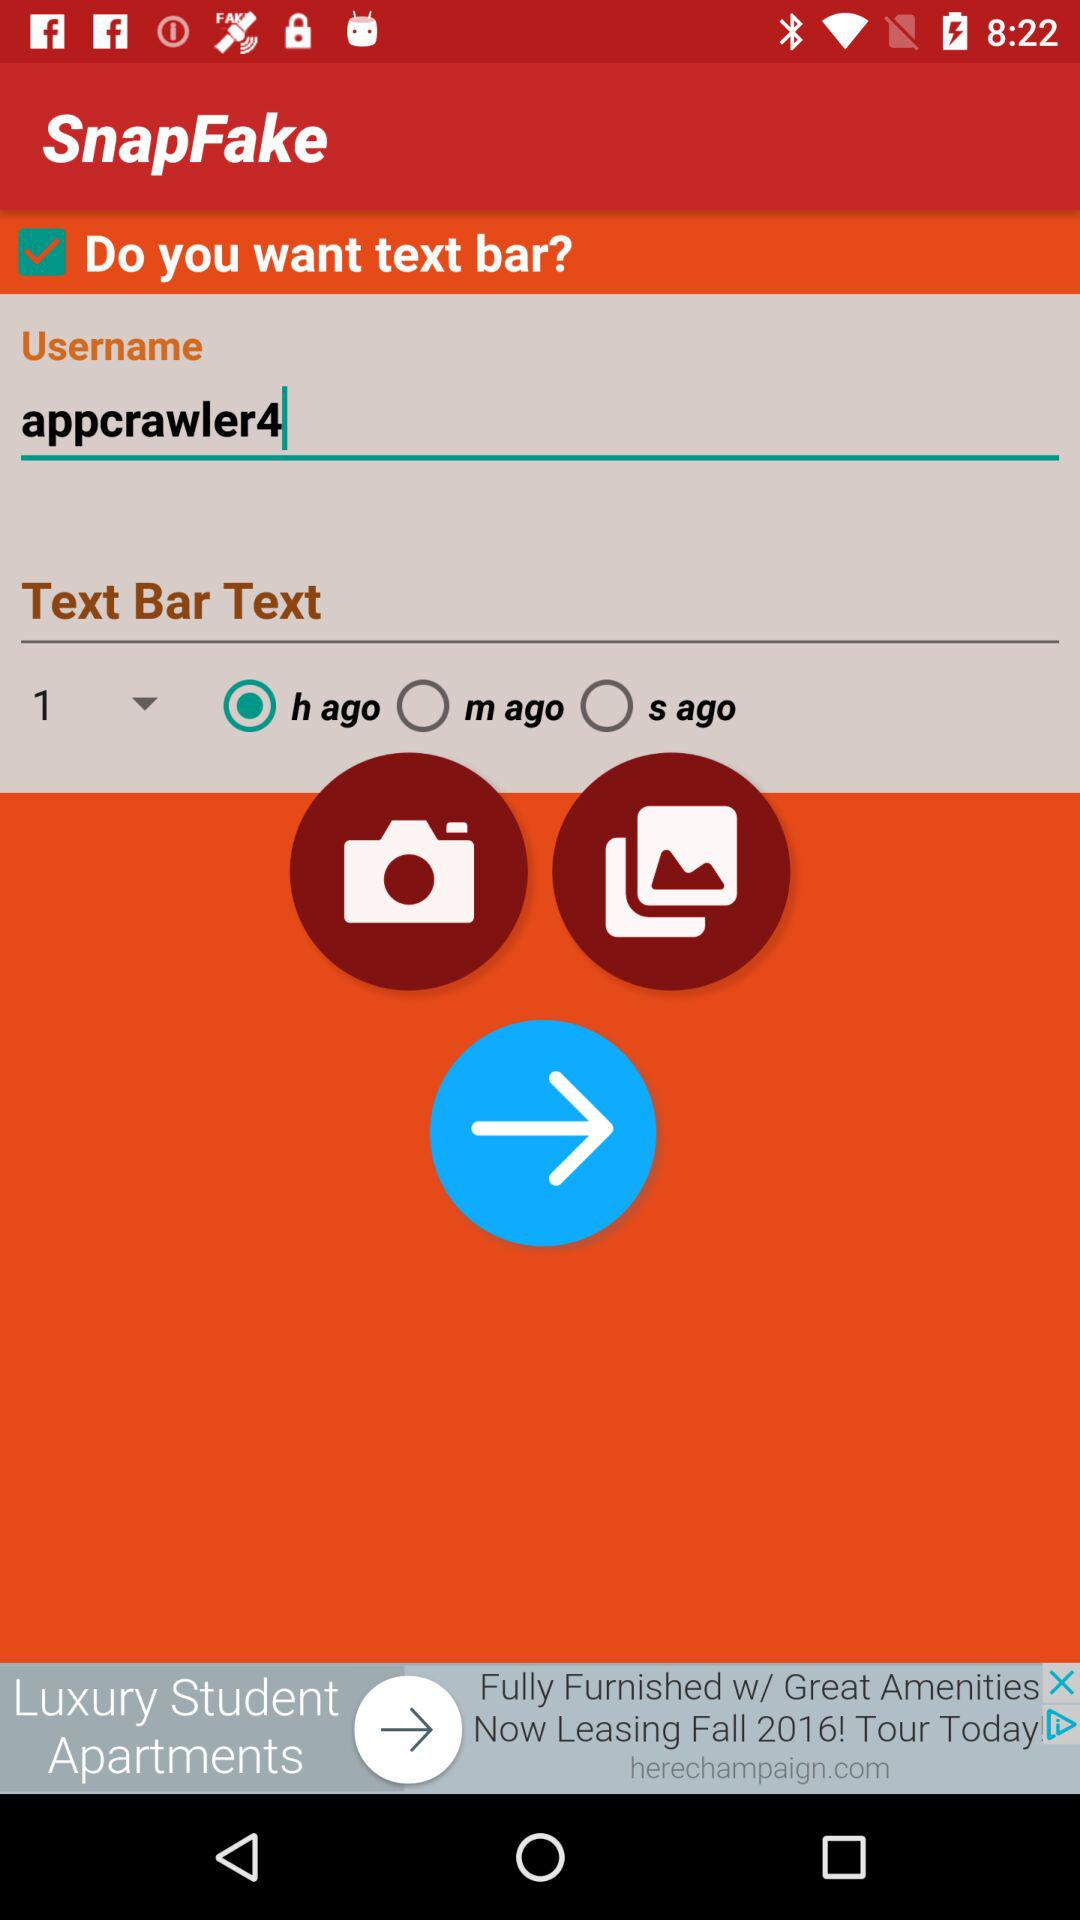What's the application name? The application name is "SnapFake". 